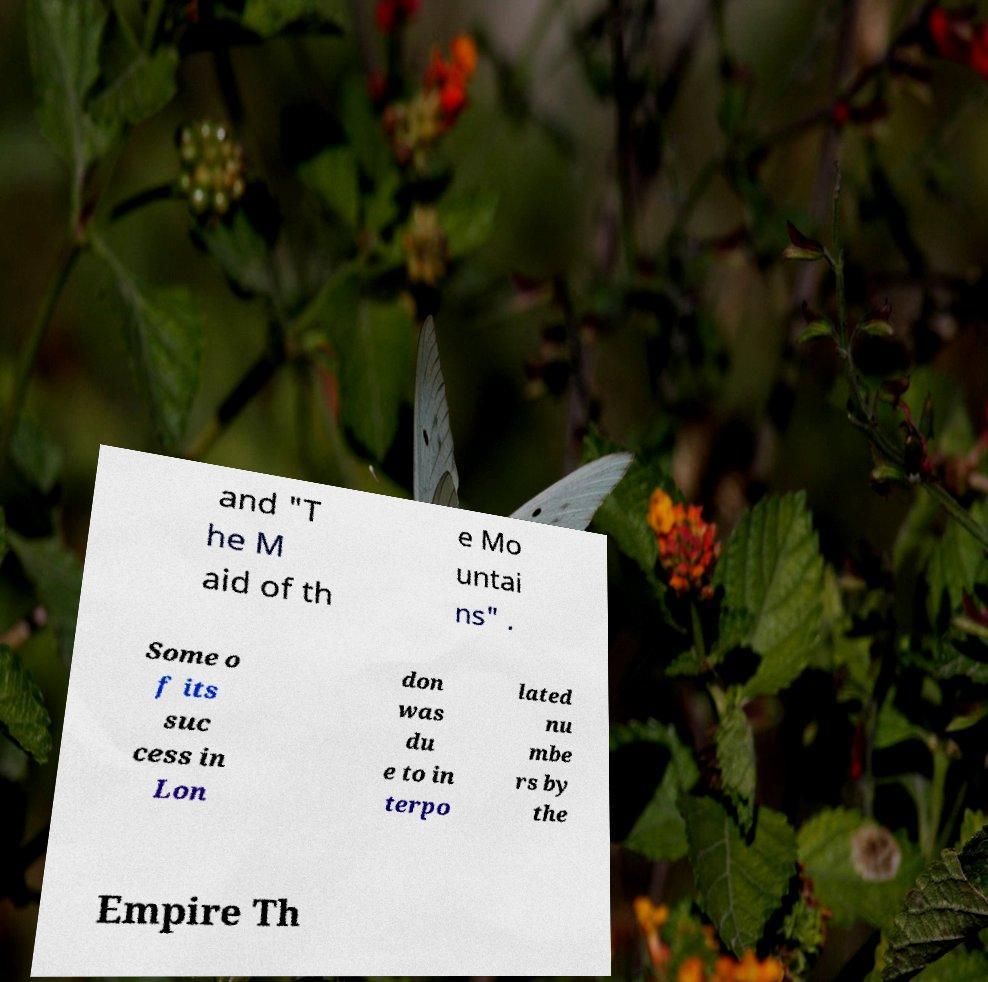I need the written content from this picture converted into text. Can you do that? and "T he M aid of th e Mo untai ns" . Some o f its suc cess in Lon don was du e to in terpo lated nu mbe rs by the Empire Th 